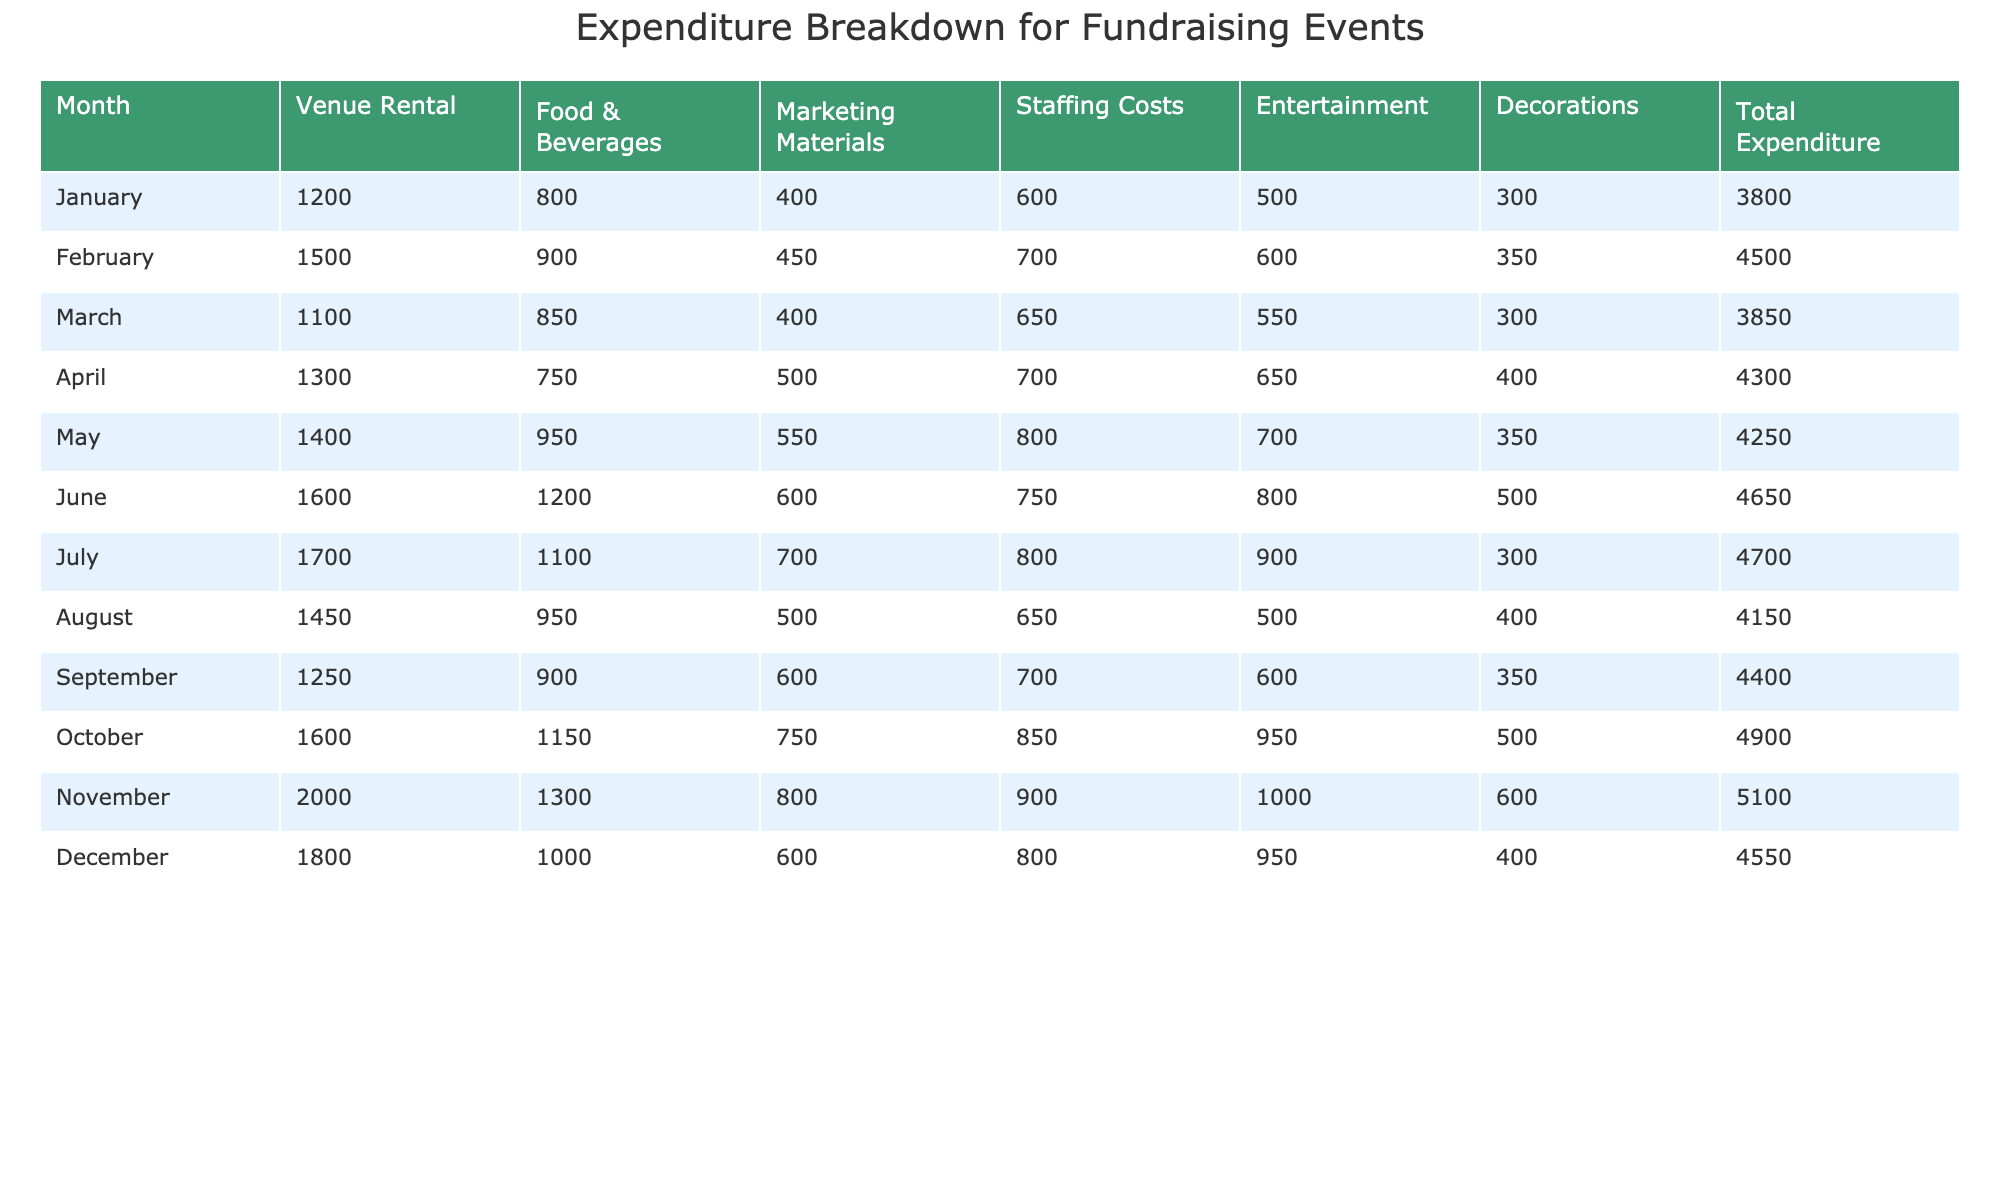What was the total expenditure for the month of April? From the table, I can see that the total expenditure for April is explicitly listed as 4300.
Answer: 4300 Which month had the highest entertainment costs? By examining the Entertainment column, I observe that November has the highest entry at 1000.
Answer: November What is the average venue rental cost over the year? To find the average venue rental, sum the venue rental costs across all months (1200 + 1500 + 1100 + 1300 + 1400 + 1600 + 1700 + 1450 + 1250 + 1600 + 2000 + 1800 = 18300) and divide by the 12 months. 18300 / 12 = 1525.
Answer: 1525 Did the food and beverage costs increase from January to February? Comparing the Food & Beverages costs for January (800) and February (900), it indicates a rise.
Answer: Yes What is the total expenditure for the second half of the year? To find this, I will sum the total expenditures from July to December: (4700 + 4150 + 4400 + 4900 + 5100 + 4550 = 28600). Therefore, the total is 28600.
Answer: 28600 In which month did the marketing materials cost the least? Looking at the Marketing Materials column, the cost is lowest in March and August, both at 400.
Answer: March and August What is the difference in total expenditure between the months of January and November? The total expenditure for January is 3800 and for November it is 5100. The difference is computed as 5100 - 3800 = 1300.
Answer: 1300 Which month had the highest total expenditure? November has the highest total expenditure listed at 5100 as seen in the Total Expenditure column.
Answer: November What percentage of the total expenditure for June was spent on food and beverages? First, I find the food and beverage costs for June, which is 1200, and the total expenditure is 4650. Then I calculate (1200 / 4650) * 100 = approximately 25.81%.
Answer: Approximately 25.81% Which two categories had the same expenditure amount in December? In December, both Staffing Costs and Decorations are listed as 800, which indicates they are the same.
Answer: Staffing Costs and Decorations 